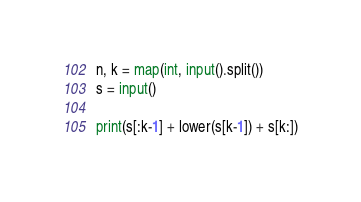<code> <loc_0><loc_0><loc_500><loc_500><_Python_>n, k = map(int, input().split())
s = input()

print(s[:k-1] + lower(s[k-1]) + s[k:])</code> 